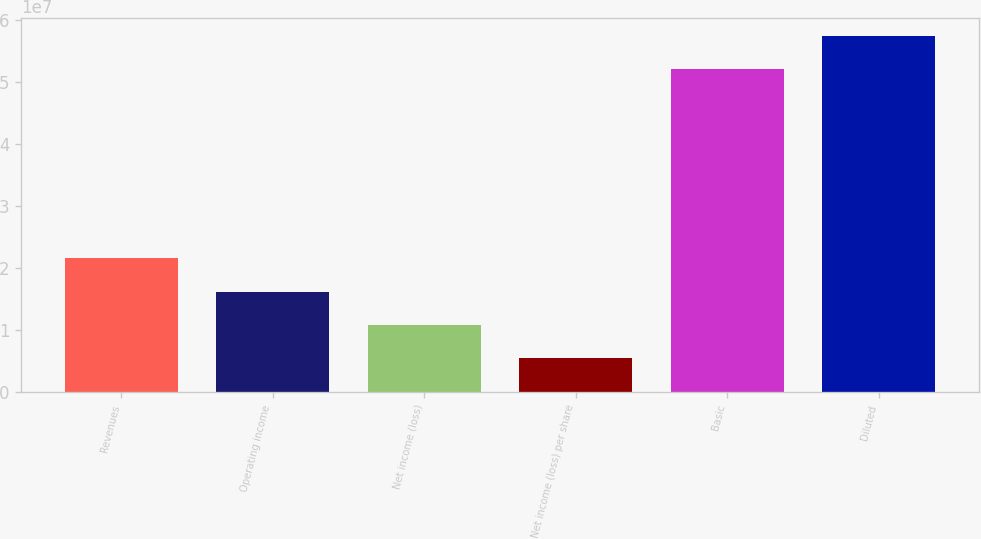Convert chart to OTSL. <chart><loc_0><loc_0><loc_500><loc_500><bar_chart><fcel>Revenues<fcel>Operating income<fcel>Net income (loss)<fcel>Net income (loss) per share<fcel>Basic<fcel>Diluted<nl><fcel>2.15423e+07<fcel>1.61567e+07<fcel>1.07711e+07<fcel>5.38556e+06<fcel>5.20187e+07<fcel>5.74043e+07<nl></chart> 